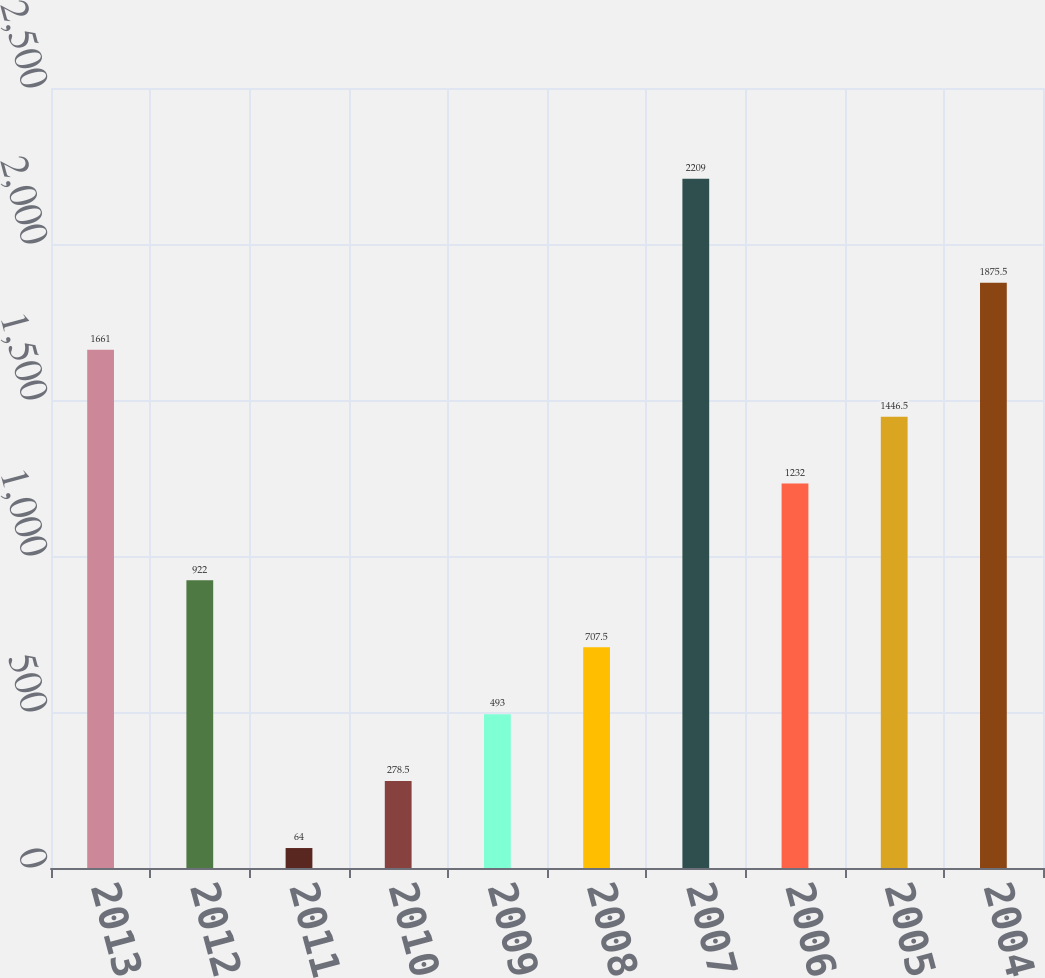Convert chart to OTSL. <chart><loc_0><loc_0><loc_500><loc_500><bar_chart><fcel>2013<fcel>2012<fcel>2011<fcel>2010<fcel>2009<fcel>2008<fcel>2007<fcel>2006<fcel>2005<fcel>2004<nl><fcel>1661<fcel>922<fcel>64<fcel>278.5<fcel>493<fcel>707.5<fcel>2209<fcel>1232<fcel>1446.5<fcel>1875.5<nl></chart> 